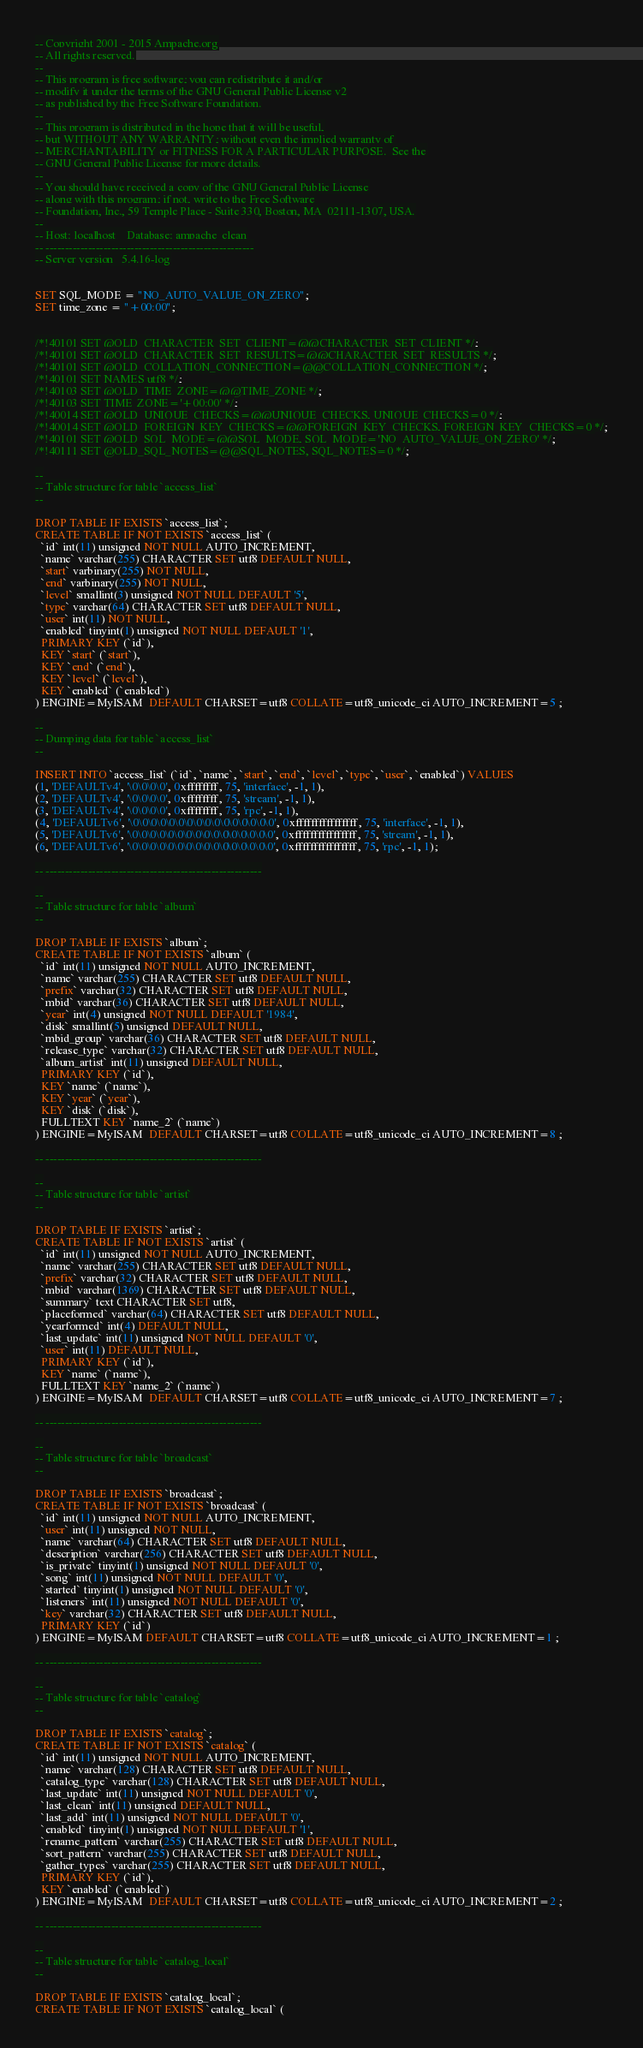Convert code to text. <code><loc_0><loc_0><loc_500><loc_500><_SQL_>-- Copyright 2001 - 2015 Ampache.org
-- All rights reserved.
--
-- This program is free software; you can redistribute it and/or
-- modify it under the terms of the GNU General Public License v2
-- as published by the Free Software Foundation.
--
-- This program is distributed in the hope that it will be useful,
-- but WITHOUT ANY WARRANTY; without even the implied warranty of
-- MERCHANTABILITY or FITNESS FOR A PARTICULAR PURPOSE.  See the
-- GNU General Public License for more details.
--
-- You should have received a copy of the GNU General Public License
-- along with this program; if not, write to the Free Software
-- Foundation, Inc., 59 Temple Place - Suite 330, Boston, MA  02111-1307, USA.
-- 
-- Host: localhost    Database: ampache_clean
-- ------------------------------------------------------
-- Server version	5.4.16-log


SET SQL_MODE = "NO_AUTO_VALUE_ON_ZERO";
SET time_zone = "+00:00";


/*!40101 SET @OLD_CHARACTER_SET_CLIENT=@@CHARACTER_SET_CLIENT */;
/*!40101 SET @OLD_CHARACTER_SET_RESULTS=@@CHARACTER_SET_RESULTS */;
/*!40101 SET @OLD_COLLATION_CONNECTION=@@COLLATION_CONNECTION */;
/*!40101 SET NAMES utf8 */;
/*!40103 SET @OLD_TIME_ZONE=@@TIME_ZONE */;
/*!40103 SET TIME_ZONE='+00:00' */;
/*!40014 SET @OLD_UNIQUE_CHECKS=@@UNIQUE_CHECKS, UNIQUE_CHECKS=0 */;
/*!40014 SET @OLD_FOREIGN_KEY_CHECKS=@@FOREIGN_KEY_CHECKS, FOREIGN_KEY_CHECKS=0 */;
/*!40101 SET @OLD_SQL_MODE=@@SQL_MODE, SQL_MODE='NO_AUTO_VALUE_ON_ZERO' */;
/*!40111 SET @OLD_SQL_NOTES=@@SQL_NOTES, SQL_NOTES=0 */;

--
-- Table structure for table `access_list`
--

DROP TABLE IF EXISTS `access_list`;
CREATE TABLE IF NOT EXISTS `access_list` (
  `id` int(11) unsigned NOT NULL AUTO_INCREMENT,
  `name` varchar(255) CHARACTER SET utf8 DEFAULT NULL,
  `start` varbinary(255) NOT NULL,
  `end` varbinary(255) NOT NULL,
  `level` smallint(3) unsigned NOT NULL DEFAULT '5',
  `type` varchar(64) CHARACTER SET utf8 DEFAULT NULL,
  `user` int(11) NOT NULL,
  `enabled` tinyint(1) unsigned NOT NULL DEFAULT '1',
  PRIMARY KEY (`id`),
  KEY `start` (`start`),
  KEY `end` (`end`),
  KEY `level` (`level`),
  KEY `enabled` (`enabled`)
) ENGINE=MyISAM  DEFAULT CHARSET=utf8 COLLATE=utf8_unicode_ci AUTO_INCREMENT=5 ;

--
-- Dumping data for table `access_list`
--

INSERT INTO `access_list` (`id`, `name`, `start`, `end`, `level`, `type`, `user`, `enabled`) VALUES
(1, 'DEFAULTv4', '\0\0\0\0', 0xffffffff, 75, 'interface', -1, 1),
(2, 'DEFAULTv4', '\0\0\0\0', 0xffffffff, 75, 'stream', -1, 1),
(3, 'DEFAULTv4', '\0\0\0\0', 0xffffffff, 75, 'rpc', -1, 1),
(4, 'DEFAULTv6', '\0\0\0\0\0\0\0\0\0\0\0\0\0\0\0\0', 0xffffffffffffffff, 75, 'interface', -1, 1),
(5, 'DEFAULTv6', '\0\0\0\0\0\0\0\0\0\0\0\0\0\0\0\0', 0xffffffffffffffff, 75, 'stream', -1, 1),
(6, 'DEFAULTv6', '\0\0\0\0\0\0\0\0\0\0\0\0\0\0\0\0', 0xffffffffffffffff, 75, 'rpc', -1, 1);

-- --------------------------------------------------------

--
-- Table structure for table `album`
--

DROP TABLE IF EXISTS `album`;
CREATE TABLE IF NOT EXISTS `album` (
  `id` int(11) unsigned NOT NULL AUTO_INCREMENT,
  `name` varchar(255) CHARACTER SET utf8 DEFAULT NULL,
  `prefix` varchar(32) CHARACTER SET utf8 DEFAULT NULL,
  `mbid` varchar(36) CHARACTER SET utf8 DEFAULT NULL,
  `year` int(4) unsigned NOT NULL DEFAULT '1984',
  `disk` smallint(5) unsigned DEFAULT NULL,
  `mbid_group` varchar(36) CHARACTER SET utf8 DEFAULT NULL,
  `release_type` varchar(32) CHARACTER SET utf8 DEFAULT NULL,
  `album_artist` int(11) unsigned DEFAULT NULL,
  PRIMARY KEY (`id`),
  KEY `name` (`name`),
  KEY `year` (`year`),
  KEY `disk` (`disk`),
  FULLTEXT KEY `name_2` (`name`)
) ENGINE=MyISAM  DEFAULT CHARSET=utf8 COLLATE=utf8_unicode_ci AUTO_INCREMENT=8 ;

-- --------------------------------------------------------

--
-- Table structure for table `artist`
--

DROP TABLE IF EXISTS `artist`;
CREATE TABLE IF NOT EXISTS `artist` (
  `id` int(11) unsigned NOT NULL AUTO_INCREMENT,
  `name` varchar(255) CHARACTER SET utf8 DEFAULT NULL,
  `prefix` varchar(32) CHARACTER SET utf8 DEFAULT NULL,
  `mbid` varchar(1369) CHARACTER SET utf8 DEFAULT NULL,
  `summary` text CHARACTER SET utf8,
  `placeformed` varchar(64) CHARACTER SET utf8 DEFAULT NULL,
  `yearformed` int(4) DEFAULT NULL,
  `last_update` int(11) unsigned NOT NULL DEFAULT '0',
  `user` int(11) DEFAULT NULL,
  PRIMARY KEY (`id`),
  KEY `name` (`name`),
  FULLTEXT KEY `name_2` (`name`)
) ENGINE=MyISAM  DEFAULT CHARSET=utf8 COLLATE=utf8_unicode_ci AUTO_INCREMENT=7 ;

-- --------------------------------------------------------

--
-- Table structure for table `broadcast`
--

DROP TABLE IF EXISTS `broadcast`;
CREATE TABLE IF NOT EXISTS `broadcast` (
  `id` int(11) unsigned NOT NULL AUTO_INCREMENT,
  `user` int(11) unsigned NOT NULL,
  `name` varchar(64) CHARACTER SET utf8 DEFAULT NULL,
  `description` varchar(256) CHARACTER SET utf8 DEFAULT NULL,
  `is_private` tinyint(1) unsigned NOT NULL DEFAULT '0',
  `song` int(11) unsigned NOT NULL DEFAULT '0',
  `started` tinyint(1) unsigned NOT NULL DEFAULT '0',
  `listeners` int(11) unsigned NOT NULL DEFAULT '0',
  `key` varchar(32) CHARACTER SET utf8 DEFAULT NULL,
  PRIMARY KEY (`id`)
) ENGINE=MyISAM DEFAULT CHARSET=utf8 COLLATE=utf8_unicode_ci AUTO_INCREMENT=1 ;

-- --------------------------------------------------------

--
-- Table structure for table `catalog`
--

DROP TABLE IF EXISTS `catalog`;
CREATE TABLE IF NOT EXISTS `catalog` (
  `id` int(11) unsigned NOT NULL AUTO_INCREMENT,
  `name` varchar(128) CHARACTER SET utf8 DEFAULT NULL,
  `catalog_type` varchar(128) CHARACTER SET utf8 DEFAULT NULL,
  `last_update` int(11) unsigned NOT NULL DEFAULT '0',
  `last_clean` int(11) unsigned DEFAULT NULL,
  `last_add` int(11) unsigned NOT NULL DEFAULT '0',
  `enabled` tinyint(1) unsigned NOT NULL DEFAULT '1',
  `rename_pattern` varchar(255) CHARACTER SET utf8 DEFAULT NULL,
  `sort_pattern` varchar(255) CHARACTER SET utf8 DEFAULT NULL,
  `gather_types` varchar(255) CHARACTER SET utf8 DEFAULT NULL,
  PRIMARY KEY (`id`),
  KEY `enabled` (`enabled`)
) ENGINE=MyISAM  DEFAULT CHARSET=utf8 COLLATE=utf8_unicode_ci AUTO_INCREMENT=2 ;

-- --------------------------------------------------------

--
-- Table structure for table `catalog_local`
--

DROP TABLE IF EXISTS `catalog_local`;
CREATE TABLE IF NOT EXISTS `catalog_local` (</code> 